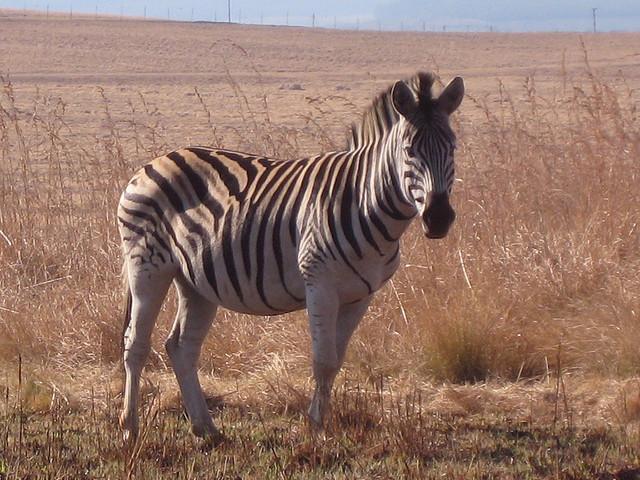What animal is in the field?
Short answer required. Zebra. Is this zebra in the wild?
Keep it brief. Yes. Is the zebra looking at the camera?
Quick response, please. Yes. Are all the zebras facing the camera?
Quick response, please. Yes. 